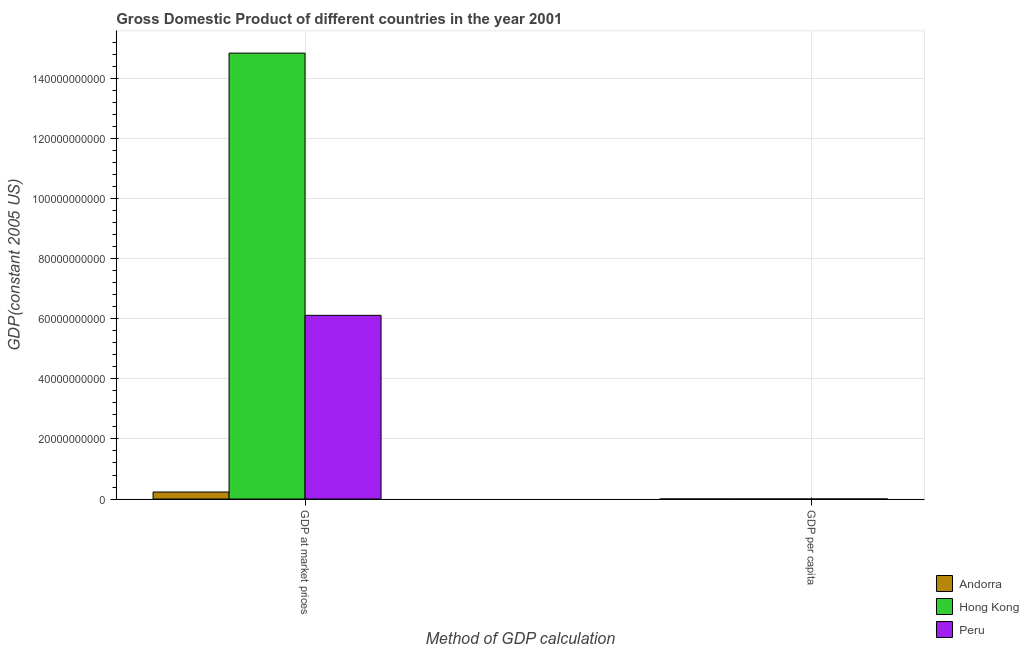Are the number of bars per tick equal to the number of legend labels?
Offer a terse response. Yes. Are the number of bars on each tick of the X-axis equal?
Offer a very short reply. Yes. What is the label of the 1st group of bars from the left?
Offer a terse response. GDP at market prices. What is the gdp per capita in Peru?
Keep it short and to the point. 2329. Across all countries, what is the maximum gdp per capita?
Your response must be concise. 3.45e+04. Across all countries, what is the minimum gdp per capita?
Keep it short and to the point. 2329. In which country was the gdp at market prices maximum?
Make the answer very short. Hong Kong. In which country was the gdp at market prices minimum?
Your response must be concise. Andorra. What is the total gdp per capita in the graph?
Keep it short and to the point. 5.89e+04. What is the difference between the gdp at market prices in Peru and that in Andorra?
Ensure brevity in your answer.  5.88e+1. What is the difference between the gdp per capita in Hong Kong and the gdp at market prices in Peru?
Provide a succinct answer. -6.12e+1. What is the average gdp per capita per country?
Keep it short and to the point. 1.96e+04. What is the difference between the gdp at market prices and gdp per capita in Peru?
Your answer should be very brief. 6.12e+1. In how many countries, is the gdp per capita greater than 36000000000 US$?
Make the answer very short. 0. What is the ratio of the gdp at market prices in Andorra to that in Hong Kong?
Keep it short and to the point. 0.02. In how many countries, is the gdp at market prices greater than the average gdp at market prices taken over all countries?
Your answer should be very brief. 1. What does the 2nd bar from the left in GDP per capita represents?
Your answer should be compact. Hong Kong. What does the 2nd bar from the right in GDP at market prices represents?
Your answer should be compact. Hong Kong. How many bars are there?
Your response must be concise. 6. Are all the bars in the graph horizontal?
Your response must be concise. No. How many countries are there in the graph?
Give a very brief answer. 3. What is the difference between two consecutive major ticks on the Y-axis?
Give a very brief answer. 2.00e+1. Are the values on the major ticks of Y-axis written in scientific E-notation?
Keep it short and to the point. No. Does the graph contain any zero values?
Provide a succinct answer. No. Does the graph contain grids?
Your answer should be very brief. Yes. Where does the legend appear in the graph?
Offer a terse response. Bottom right. How many legend labels are there?
Offer a very short reply. 3. How are the legend labels stacked?
Offer a very short reply. Vertical. What is the title of the graph?
Your response must be concise. Gross Domestic Product of different countries in the year 2001. What is the label or title of the X-axis?
Offer a terse response. Method of GDP calculation. What is the label or title of the Y-axis?
Ensure brevity in your answer.  GDP(constant 2005 US). What is the GDP(constant 2005 US) of Andorra in GDP at market prices?
Offer a terse response. 2.34e+09. What is the GDP(constant 2005 US) of Hong Kong in GDP at market prices?
Provide a succinct answer. 1.48e+11. What is the GDP(constant 2005 US) of Peru in GDP at market prices?
Your answer should be compact. 6.12e+1. What is the GDP(constant 2005 US) in Andorra in GDP per capita?
Provide a short and direct response. 3.45e+04. What is the GDP(constant 2005 US) of Hong Kong in GDP per capita?
Your answer should be very brief. 2.21e+04. What is the GDP(constant 2005 US) of Peru in GDP per capita?
Ensure brevity in your answer.  2329. Across all Method of GDP calculation, what is the maximum GDP(constant 2005 US) of Andorra?
Offer a very short reply. 2.34e+09. Across all Method of GDP calculation, what is the maximum GDP(constant 2005 US) in Hong Kong?
Provide a succinct answer. 1.48e+11. Across all Method of GDP calculation, what is the maximum GDP(constant 2005 US) of Peru?
Your answer should be very brief. 6.12e+1. Across all Method of GDP calculation, what is the minimum GDP(constant 2005 US) of Andorra?
Keep it short and to the point. 3.45e+04. Across all Method of GDP calculation, what is the minimum GDP(constant 2005 US) in Hong Kong?
Keep it short and to the point. 2.21e+04. Across all Method of GDP calculation, what is the minimum GDP(constant 2005 US) in Peru?
Give a very brief answer. 2329. What is the total GDP(constant 2005 US) in Andorra in the graph?
Your answer should be compact. 2.34e+09. What is the total GDP(constant 2005 US) in Hong Kong in the graph?
Provide a short and direct response. 1.48e+11. What is the total GDP(constant 2005 US) in Peru in the graph?
Make the answer very short. 6.12e+1. What is the difference between the GDP(constant 2005 US) in Andorra in GDP at market prices and that in GDP per capita?
Make the answer very short. 2.34e+09. What is the difference between the GDP(constant 2005 US) in Hong Kong in GDP at market prices and that in GDP per capita?
Provide a short and direct response. 1.48e+11. What is the difference between the GDP(constant 2005 US) of Peru in GDP at market prices and that in GDP per capita?
Your answer should be compact. 6.12e+1. What is the difference between the GDP(constant 2005 US) of Andorra in GDP at market prices and the GDP(constant 2005 US) of Hong Kong in GDP per capita?
Provide a succinct answer. 2.34e+09. What is the difference between the GDP(constant 2005 US) in Andorra in GDP at market prices and the GDP(constant 2005 US) in Peru in GDP per capita?
Provide a succinct answer. 2.34e+09. What is the difference between the GDP(constant 2005 US) in Hong Kong in GDP at market prices and the GDP(constant 2005 US) in Peru in GDP per capita?
Offer a very short reply. 1.48e+11. What is the average GDP(constant 2005 US) in Andorra per Method of GDP calculation?
Offer a very short reply. 1.17e+09. What is the average GDP(constant 2005 US) of Hong Kong per Method of GDP calculation?
Make the answer very short. 7.42e+1. What is the average GDP(constant 2005 US) of Peru per Method of GDP calculation?
Give a very brief answer. 3.06e+1. What is the difference between the GDP(constant 2005 US) in Andorra and GDP(constant 2005 US) in Hong Kong in GDP at market prices?
Make the answer very short. -1.46e+11. What is the difference between the GDP(constant 2005 US) of Andorra and GDP(constant 2005 US) of Peru in GDP at market prices?
Keep it short and to the point. -5.88e+1. What is the difference between the GDP(constant 2005 US) in Hong Kong and GDP(constant 2005 US) in Peru in GDP at market prices?
Your answer should be very brief. 8.73e+1. What is the difference between the GDP(constant 2005 US) in Andorra and GDP(constant 2005 US) in Hong Kong in GDP per capita?
Your response must be concise. 1.24e+04. What is the difference between the GDP(constant 2005 US) in Andorra and GDP(constant 2005 US) in Peru in GDP per capita?
Your response must be concise. 3.22e+04. What is the difference between the GDP(constant 2005 US) of Hong Kong and GDP(constant 2005 US) of Peru in GDP per capita?
Provide a short and direct response. 1.98e+04. What is the ratio of the GDP(constant 2005 US) in Andorra in GDP at market prices to that in GDP per capita?
Give a very brief answer. 6.78e+04. What is the ratio of the GDP(constant 2005 US) in Hong Kong in GDP at market prices to that in GDP per capita?
Your answer should be very brief. 6.71e+06. What is the ratio of the GDP(constant 2005 US) in Peru in GDP at market prices to that in GDP per capita?
Give a very brief answer. 2.63e+07. What is the difference between the highest and the second highest GDP(constant 2005 US) in Andorra?
Offer a very short reply. 2.34e+09. What is the difference between the highest and the second highest GDP(constant 2005 US) in Hong Kong?
Provide a short and direct response. 1.48e+11. What is the difference between the highest and the second highest GDP(constant 2005 US) in Peru?
Provide a succinct answer. 6.12e+1. What is the difference between the highest and the lowest GDP(constant 2005 US) of Andorra?
Offer a terse response. 2.34e+09. What is the difference between the highest and the lowest GDP(constant 2005 US) of Hong Kong?
Your response must be concise. 1.48e+11. What is the difference between the highest and the lowest GDP(constant 2005 US) in Peru?
Make the answer very short. 6.12e+1. 